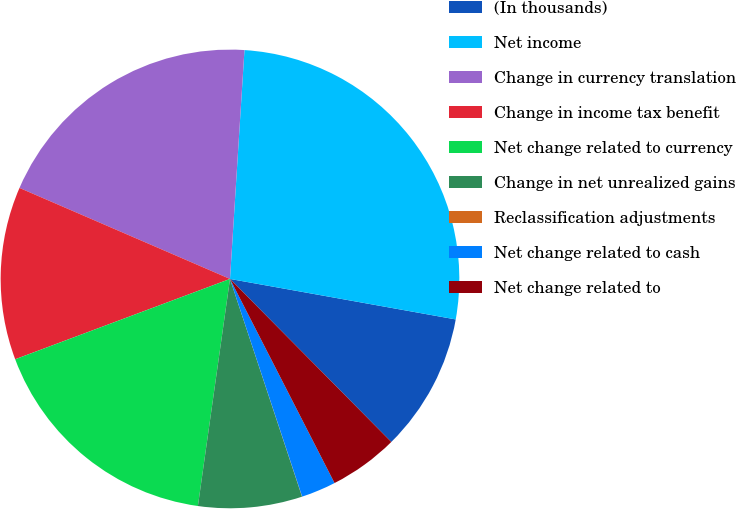Convert chart to OTSL. <chart><loc_0><loc_0><loc_500><loc_500><pie_chart><fcel>(In thousands)<fcel>Net income<fcel>Change in currency translation<fcel>Change in income tax benefit<fcel>Net change related to currency<fcel>Change in net unrealized gains<fcel>Reclassification adjustments<fcel>Net change related to cash<fcel>Net change related to<nl><fcel>9.76%<fcel>26.82%<fcel>19.51%<fcel>12.19%<fcel>17.07%<fcel>7.32%<fcel>0.01%<fcel>2.44%<fcel>4.88%<nl></chart> 